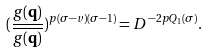Convert formula to latex. <formula><loc_0><loc_0><loc_500><loc_500>( \frac { g ( \mathbf q ) } { \overline { g ( \mathbf q ) } } ) ^ { p ( \sigma - v ) ( \sigma - 1 ) } = D ^ { - 2 p Q _ { 1 } ( \sigma ) } .</formula> 